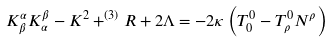Convert formula to latex. <formula><loc_0><loc_0><loc_500><loc_500>K _ { \beta } ^ { \alpha } K _ { \alpha } ^ { \beta } - K ^ { 2 } + ^ { ( 3 ) } R + 2 \Lambda = - 2 \kappa \left ( T _ { 0 } ^ { 0 } - T _ { \rho } ^ { 0 } N ^ { \rho } \right )</formula> 